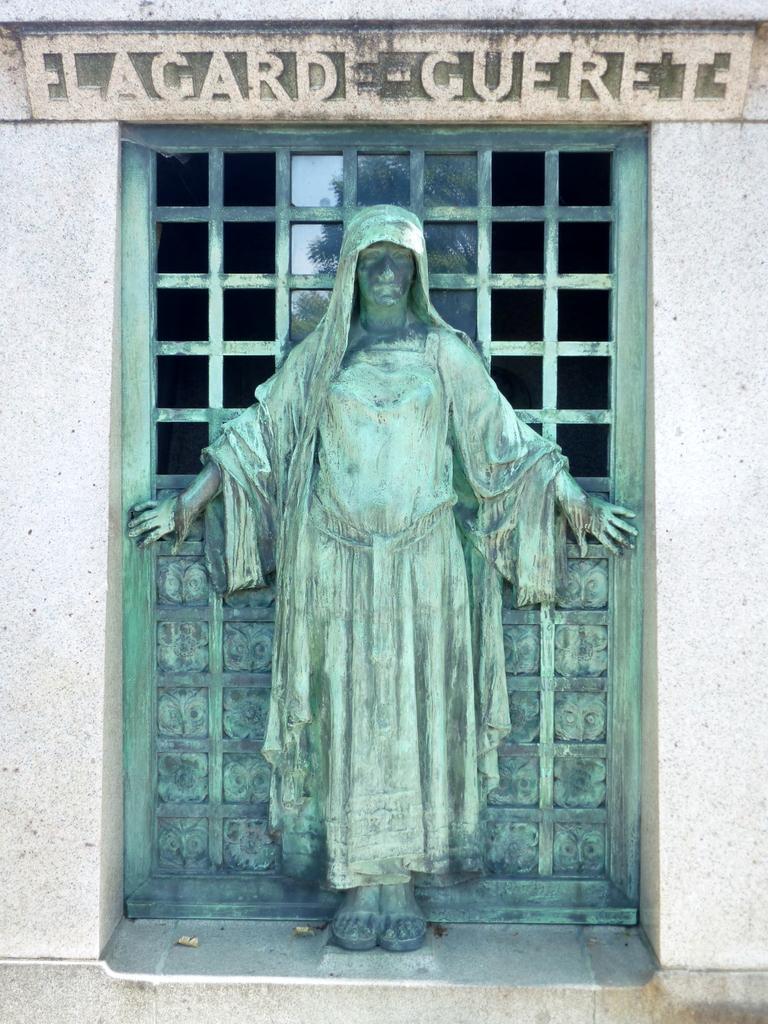Describe this image in one or two sentences. Here I can see a statue of a person which is placed on the wall. At the back of this statue there is a metal surface. This seems to be a window. At the top I can see some text. 